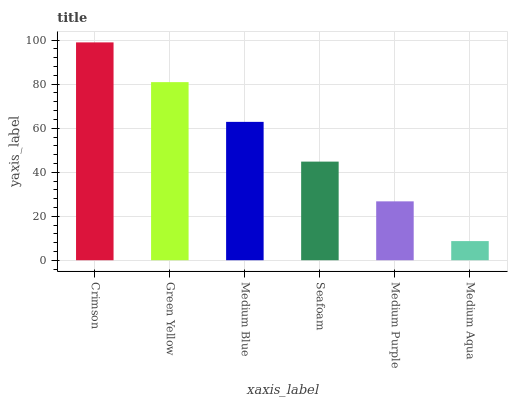Is Medium Aqua the minimum?
Answer yes or no. Yes. Is Crimson the maximum?
Answer yes or no. Yes. Is Green Yellow the minimum?
Answer yes or no. No. Is Green Yellow the maximum?
Answer yes or no. No. Is Crimson greater than Green Yellow?
Answer yes or no. Yes. Is Green Yellow less than Crimson?
Answer yes or no. Yes. Is Green Yellow greater than Crimson?
Answer yes or no. No. Is Crimson less than Green Yellow?
Answer yes or no. No. Is Medium Blue the high median?
Answer yes or no. Yes. Is Seafoam the low median?
Answer yes or no. Yes. Is Medium Aqua the high median?
Answer yes or no. No. Is Medium Aqua the low median?
Answer yes or no. No. 